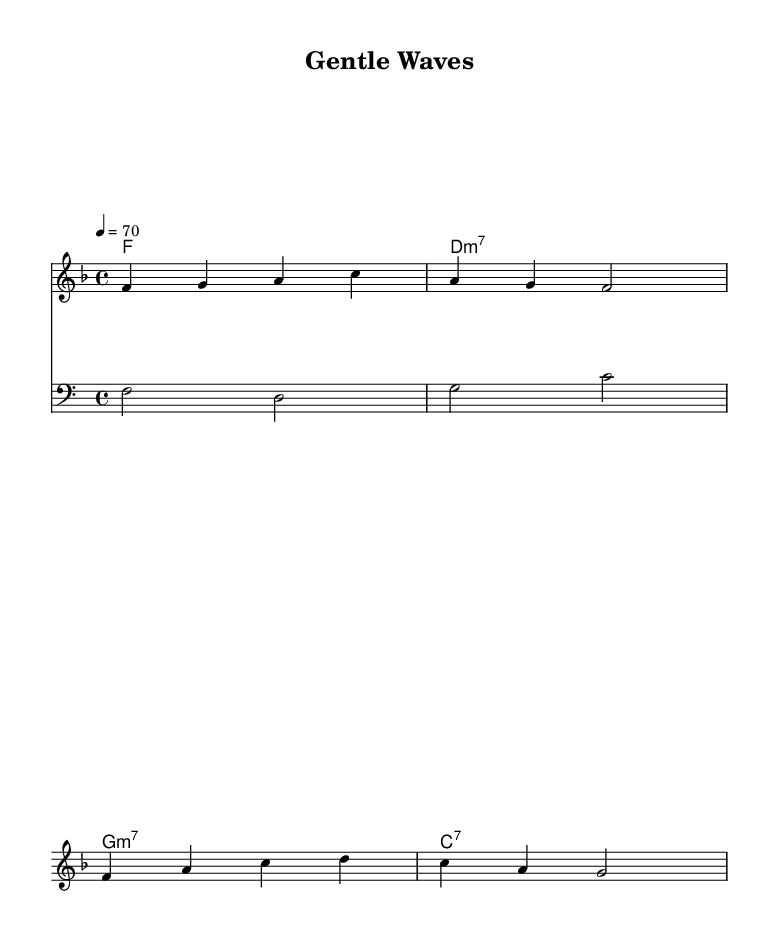What is the key signature of this music? The key signature is F major, which has one flat (B flat).
Answer: F major What is the time signature of this music? The time signature is 4/4, indicating four beats per measure.
Answer: 4/4 What is the tempo marking of this piece? The tempo marking indicates a speed of 70 beats per minute, specified as "4 = 70".
Answer: 70 What is the first note of the melody? The first note of the melody is F, which starts on the second line of the treble staff.
Answer: F How many measures are in the melody? The melody has a total of 4 measures, as indicated by the grouping of the notes.
Answer: 4 What type of seventh chord is used in the second measure of harmonies? The second measure contains a D minor seventh chord, noted as "d1:m7" in the chord mode.
Answer: D minor seventh What gives this piece its bossa nova character? The bossa nova character is developed through its syncopated rhythms and use of jazz harmonies, prominently featured in the chord progression.
Answer: Syncopation and jazz harmonies 